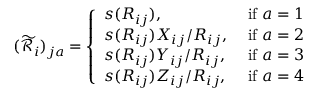<formula> <loc_0><loc_0><loc_500><loc_500>( \widetilde { \mathcal { R } } _ { i } ) _ { j a } = \left \{ \begin{array} { l l } { s ( R _ { i j } ) , } & { i f a = 1 } \\ { s ( R _ { i j } ) X _ { i j } / R _ { i j } , } & { i f a = 2 } \\ { s ( R _ { i j } ) Y _ { i j } / R _ { i j } , } & { i f a = 3 } \\ { s ( R _ { i j } ) Z _ { i j } / R _ { i j } , } & { i f a = 4 } \end{array}</formula> 